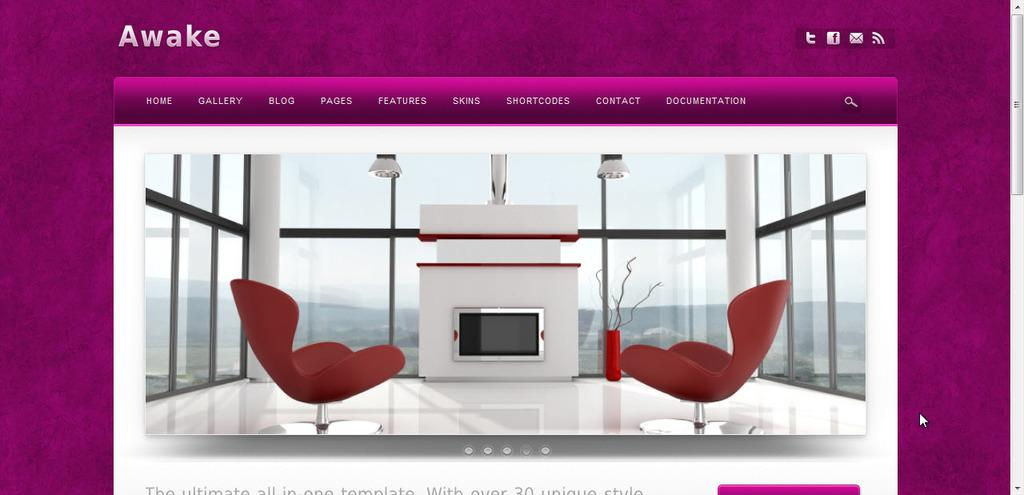<image>
Give a short and clear explanation of the subsequent image. Screen that shows two red chairs by a fireplace and the word AWAKE on top. 